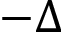Convert formula to latex. <formula><loc_0><loc_0><loc_500><loc_500>- \Delta</formula> 